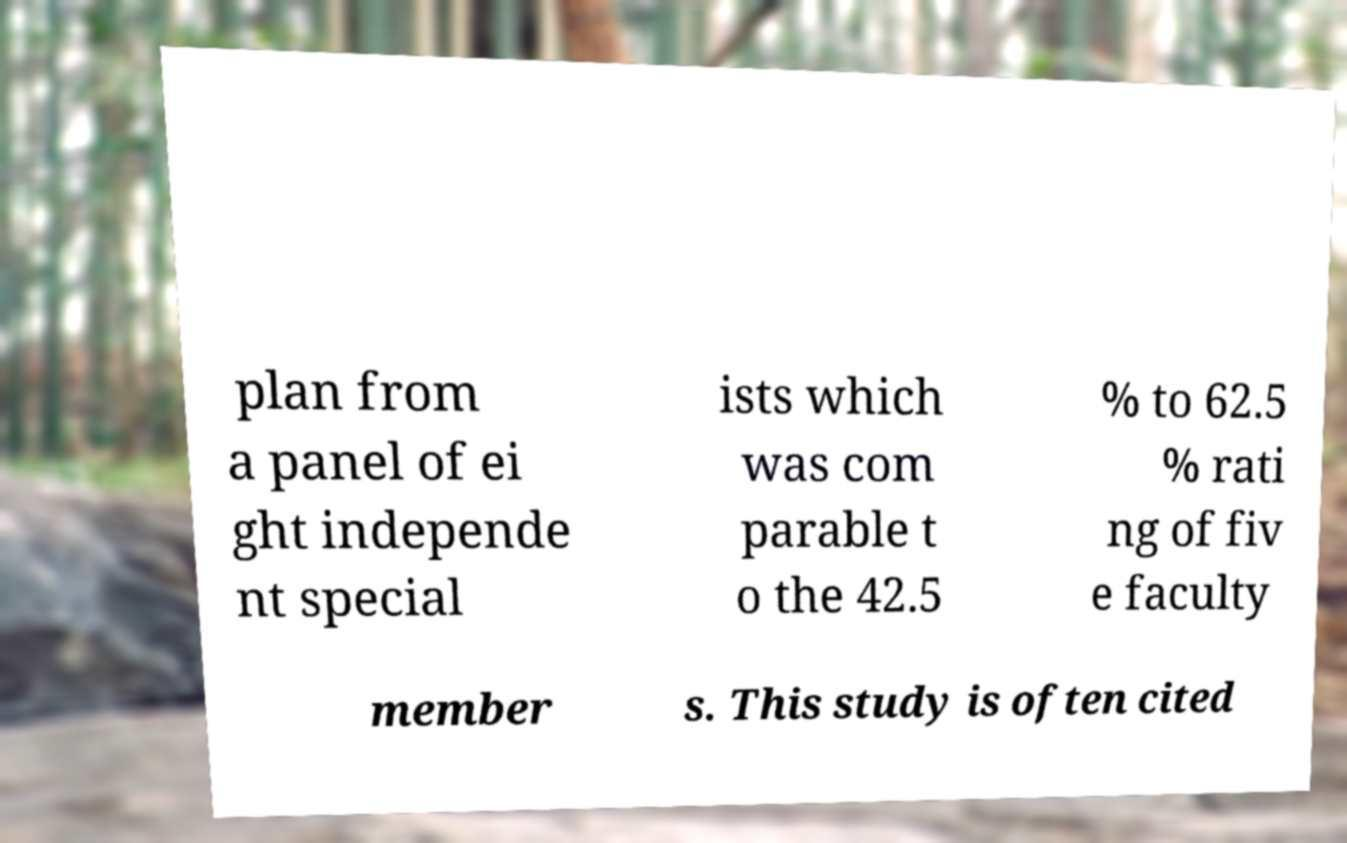There's text embedded in this image that I need extracted. Can you transcribe it verbatim? plan from a panel of ei ght independe nt special ists which was com parable t o the 42.5 % to 62.5 % rati ng of fiv e faculty member s. This study is often cited 